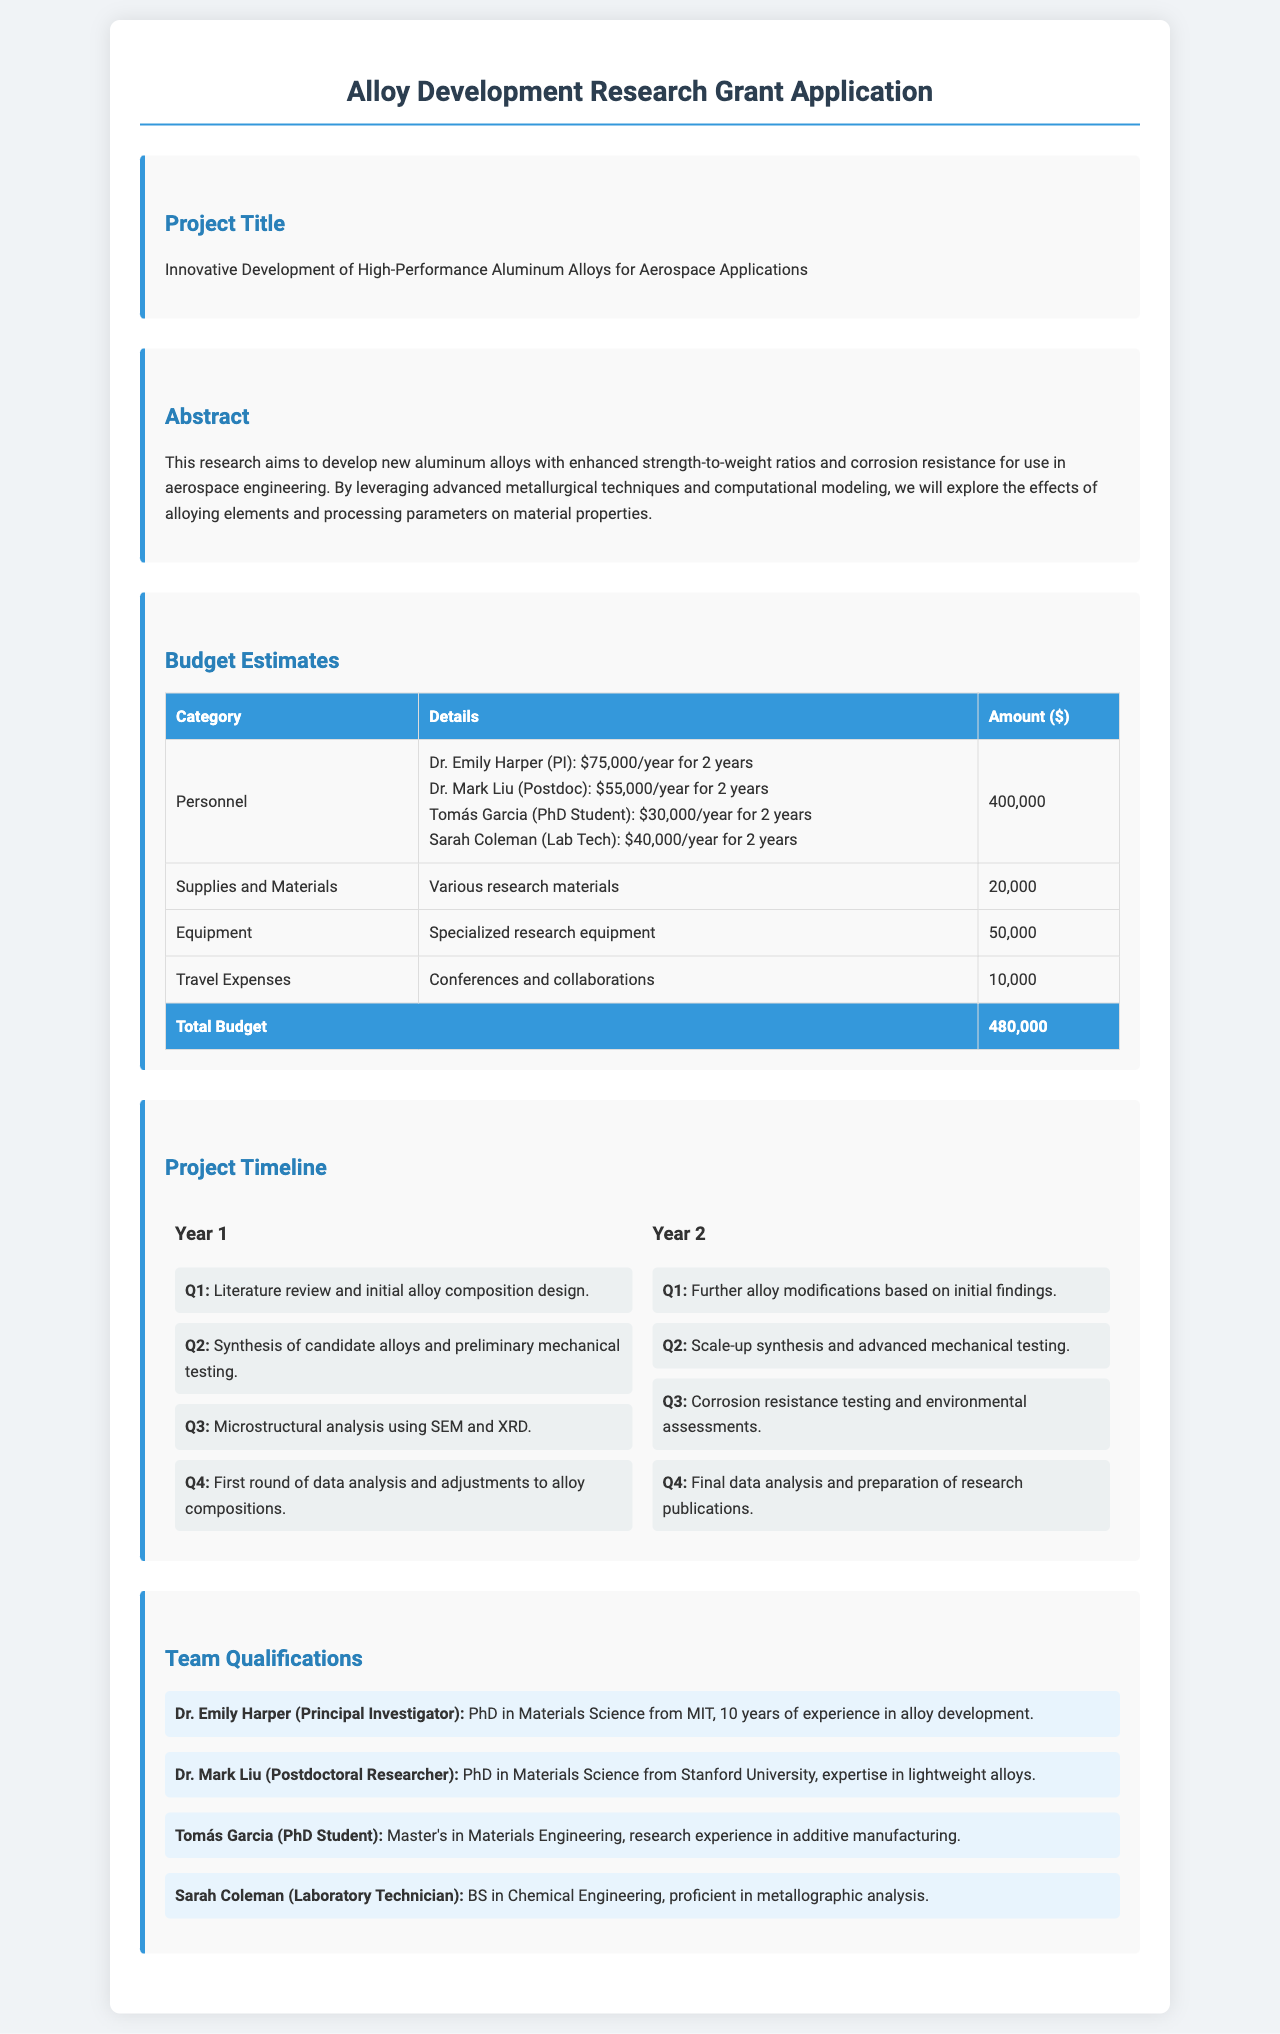What is the project title? The project title is a specific section in the document that states the focus of the research, which is "Innovative Development of High-Performance Aluminum Alloys for Aerospace Applications."
Answer: Innovative Development of High-Performance Aluminum Alloys for Aerospace Applications Who is the Principal Investigator? The Principal Investigator is mentioned in the Team Qualifications section, identifying the lead researcher responsible for the project, which is Dr. Emily Harper.
Answer: Dr. Emily Harper What is the total budget estimate? The total budget is the sum of all budget categories in the document, which is outlined in the Budget Estimates section, amounting to $480,000.
Answer: $480,000 How many years will the project span? The project timeline outlines activities for two distinct years, indicating the duration of the research project.
Answer: 2 years What is the budget for Travel Expenses? The budget for Travel Expenses is detailed in the Budget Estimates section, specifying the allocation for travel-related activities.
Answer: 10,000 Which quarter involves the synthesis of candidate alloys? This question requires looking at the Project Timeline to find the specific quarter where this activity occurs, which is identified as Q2 of Year 1.
Answer: Q2 What type of analysis will be conducted in Q3 of Year 1? The Project Timeline includes a mention of activities for Q3 of Year 1, which involves microstructural analysis using SEM and XRD.
Answer: Microstructural analysis using SEM and XRD What is the main goal of the research? The Abstract elaborates on the purpose of the research, emphasizing the development of new aluminum alloys with enhanced properties for aerospace applications.
Answer: Enhanced strength-to-weight ratios and corrosion resistance for aerospace engineering Who has expertise in lightweight alloys? The Team Qualifications section specifies the relevant expertise of individuals, revealing that Dr. Mark Liu has expertise in lightweight alloys.
Answer: Dr. Mark Liu 